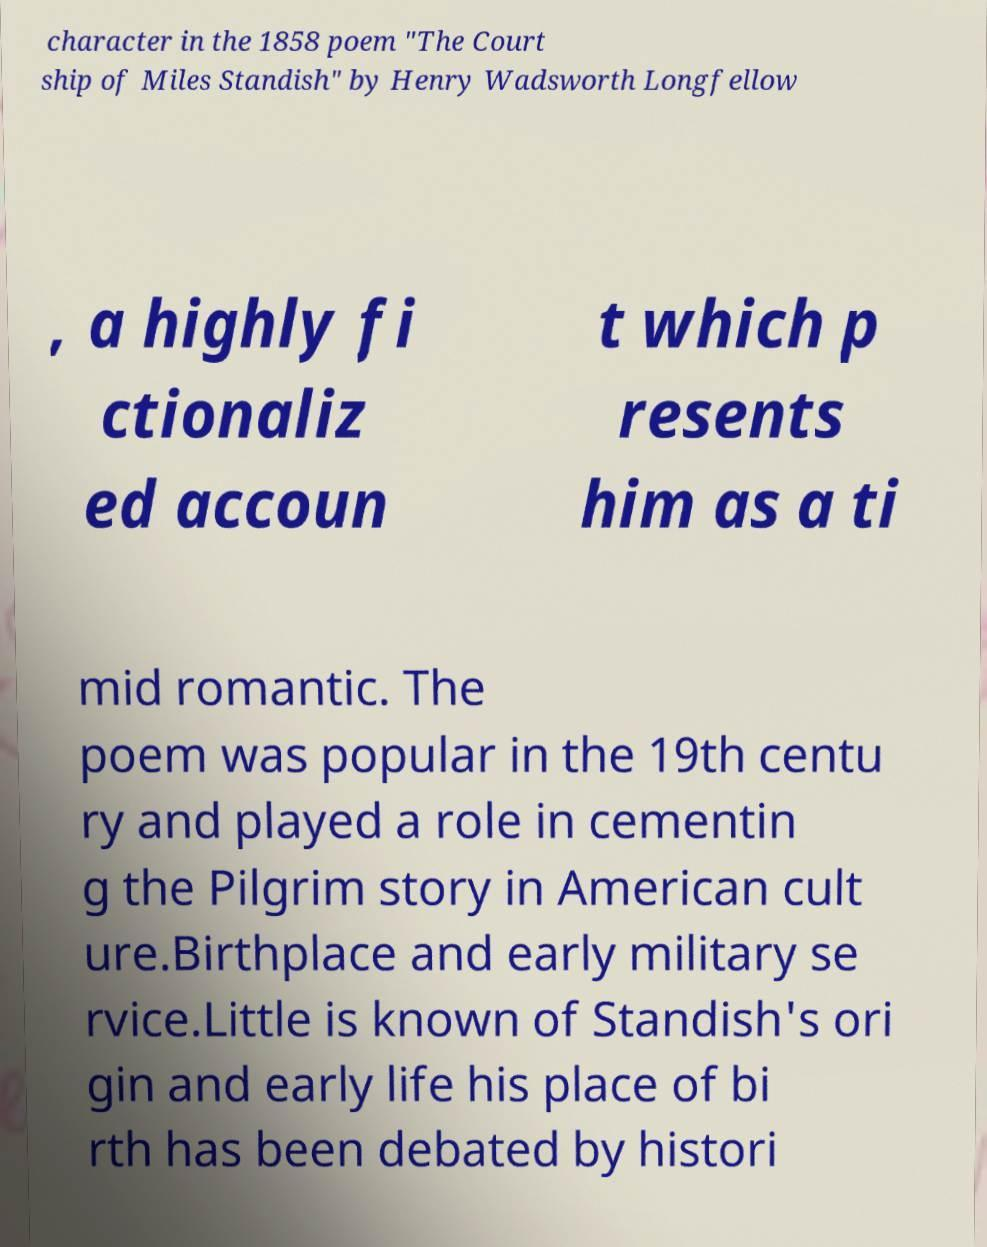I need the written content from this picture converted into text. Can you do that? character in the 1858 poem "The Court ship of Miles Standish" by Henry Wadsworth Longfellow , a highly fi ctionaliz ed accoun t which p resents him as a ti mid romantic. The poem was popular in the 19th centu ry and played a role in cementin g the Pilgrim story in American cult ure.Birthplace and early military se rvice.Little is known of Standish's ori gin and early life his place of bi rth has been debated by histori 